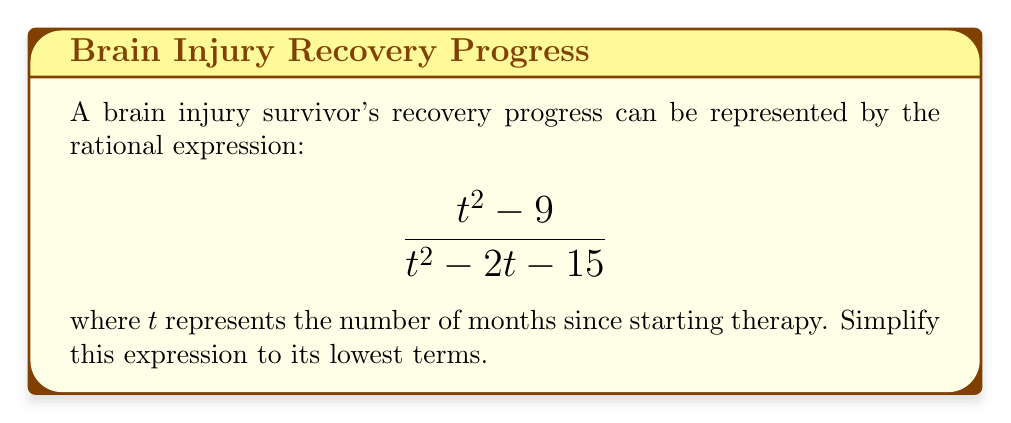Can you answer this question? Let's simplify this rational expression step by step:

1) First, we need to factor both the numerator and denominator:

   Numerator: $t^2 - 9 = (t+3)(t-3)$
   Denominator: $t^2 - 2t - 15 = (t+3)(t-5)$

2) Now our expression looks like this:

   $$\frac{(t+3)(t-3)}{(t+3)(t-5)}$$

3) We can see that $(t+3)$ is a common factor in both the numerator and denominator. We can cancel this out:

   $$\frac{\cancel{(t+3)}(t-3)}{\cancel{(t+3)}(t-5)}$$

4) After cancellation, we're left with:

   $$\frac{t-3}{t-5}$$

5) This fraction cannot be simplified further as there are no common factors between the numerator and denominator.

6) Note: The domain of this function is all real numbers except 5, as $t-5$ in the denominator cannot equal zero.
Answer: $\frac{t-3}{t-5}$, $t \neq 5$ 